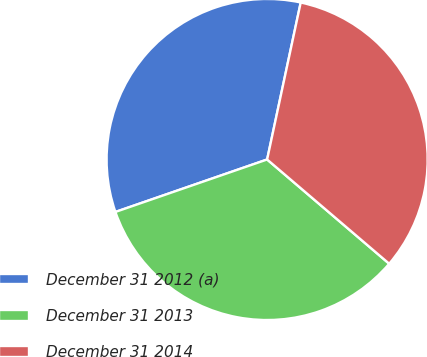<chart> <loc_0><loc_0><loc_500><loc_500><pie_chart><fcel>December 31 2012 (a)<fcel>December 31 2013<fcel>December 31 2014<nl><fcel>33.65%<fcel>33.45%<fcel>32.89%<nl></chart> 